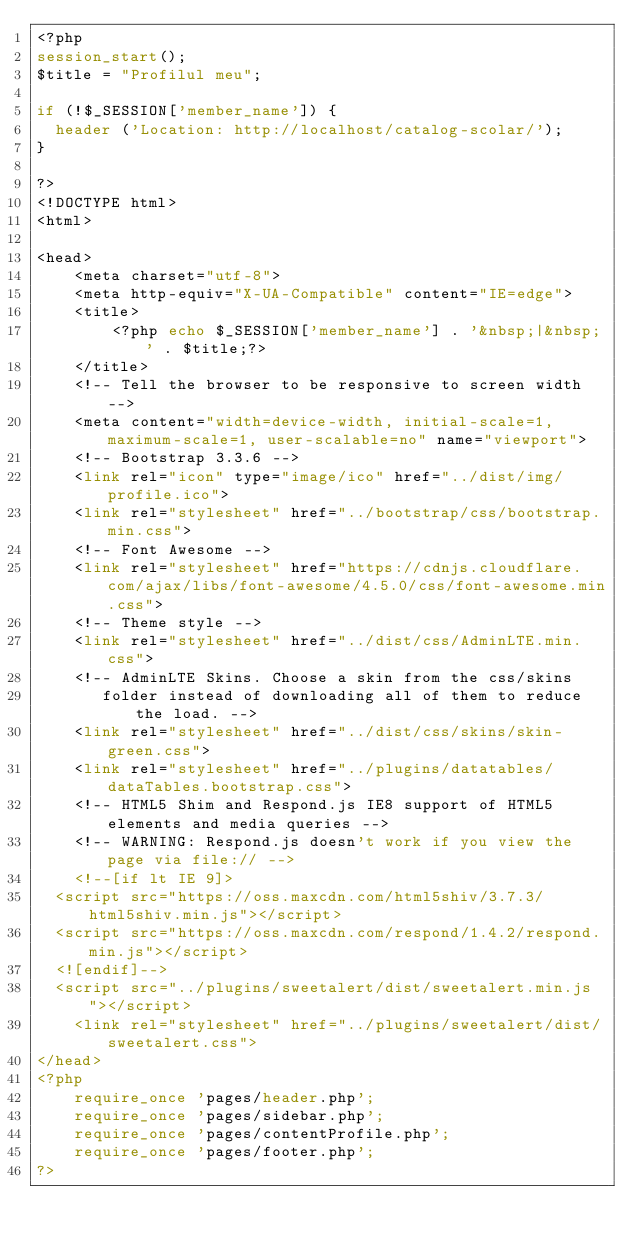<code> <loc_0><loc_0><loc_500><loc_500><_PHP_><?php 
session_start(); 
$title = "Profilul meu";

if (!$_SESSION['member_name']) {
  header ('Location: http://localhost/catalog-scolar/');
}

?>
<!DOCTYPE html>
<html>

<head>
    <meta charset="utf-8">
    <meta http-equiv="X-UA-Compatible" content="IE=edge">
    <title>
        <?php echo $_SESSION['member_name'] . '&nbsp;|&nbsp;' . $title;?>
    </title>
    <!-- Tell the browser to be responsive to screen width -->
    <meta content="width=device-width, initial-scale=1, maximum-scale=1, user-scalable=no" name="viewport">
    <!-- Bootstrap 3.3.6 -->
    <link rel="icon" type="image/ico" href="../dist/img/profile.ico">
    <link rel="stylesheet" href="../bootstrap/css/bootstrap.min.css">
    <!-- Font Awesome -->
    <link rel="stylesheet" href="https://cdnjs.cloudflare.com/ajax/libs/font-awesome/4.5.0/css/font-awesome.min.css">
    <!-- Theme style -->
    <link rel="stylesheet" href="../dist/css/AdminLTE.min.css">
    <!-- AdminLTE Skins. Choose a skin from the css/skins
       folder instead of downloading all of them to reduce the load. -->
    <link rel="stylesheet" href="../dist/css/skins/skin-green.css">
    <link rel="stylesheet" href="../plugins/datatables/dataTables.bootstrap.css">
    <!-- HTML5 Shim and Respond.js IE8 support of HTML5 elements and media queries -->
    <!-- WARNING: Respond.js doesn't work if you view the page via file:// -->
    <!--[if lt IE 9]>
  <script src="https://oss.maxcdn.com/html5shiv/3.7.3/html5shiv.min.js"></script>
  <script src="https://oss.maxcdn.com/respond/1.4.2/respond.min.js"></script>
  <![endif]-->
  <script src="../plugins/sweetalert/dist/sweetalert.min.js"></script>
    <link rel="stylesheet" href="../plugins/sweetalert/dist/sweetalert.css">
</head>
<?php
	require_once 'pages/header.php';
	require_once 'pages/sidebar.php';
	require_once 'pages/contentProfile.php'; 
	require_once 'pages/footer.php';
?>
</code> 